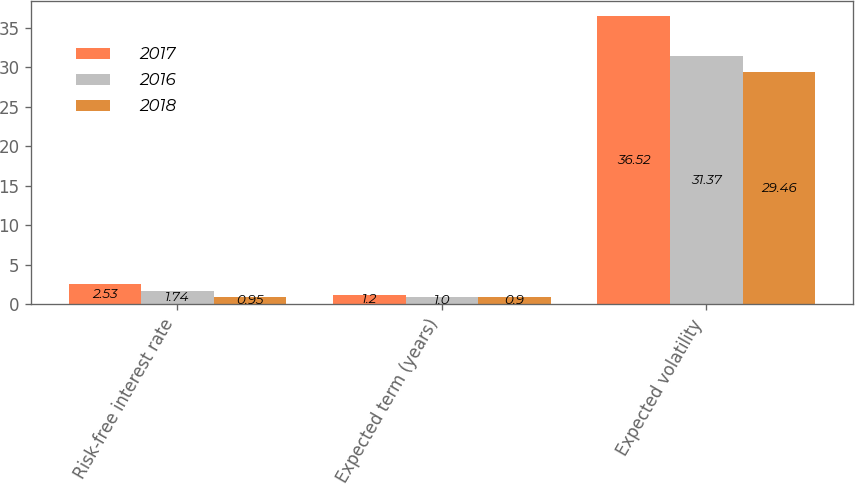<chart> <loc_0><loc_0><loc_500><loc_500><stacked_bar_chart><ecel><fcel>Risk-free interest rate<fcel>Expected term (years)<fcel>Expected volatility<nl><fcel>2017<fcel>2.53<fcel>1.2<fcel>36.52<nl><fcel>2016<fcel>1.74<fcel>1<fcel>31.37<nl><fcel>2018<fcel>0.95<fcel>0.9<fcel>29.46<nl></chart> 